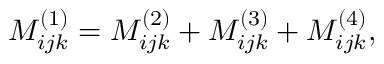<formula> <loc_0><loc_0><loc_500><loc_500>M _ { i j k } ^ { ( 1 ) } = M _ { i j k } ^ { ( 2 ) } + M _ { i j k } ^ { ( 3 ) } + M _ { i j k } ^ { ( 4 ) } ,</formula> 